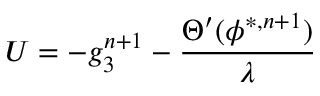<formula> <loc_0><loc_0><loc_500><loc_500>U = - g _ { 3 } ^ { n + 1 } - \frac { \Theta ^ { \prime } ( \phi ^ { * , n + 1 } ) } { \lambda }</formula> 